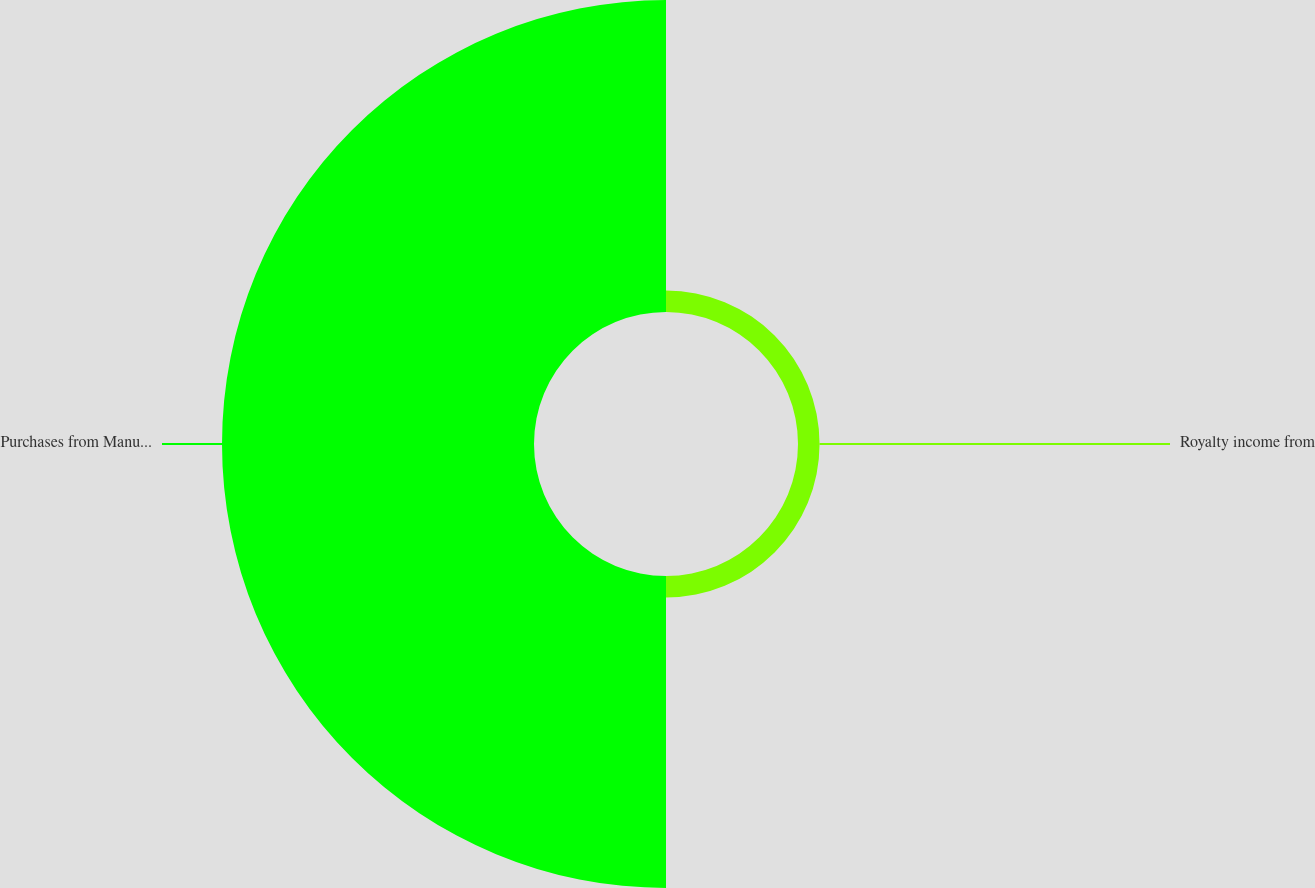<chart> <loc_0><loc_0><loc_500><loc_500><pie_chart><fcel>Royalty income from<fcel>Purchases from Manufacturing<nl><fcel>6.46%<fcel>93.54%<nl></chart> 